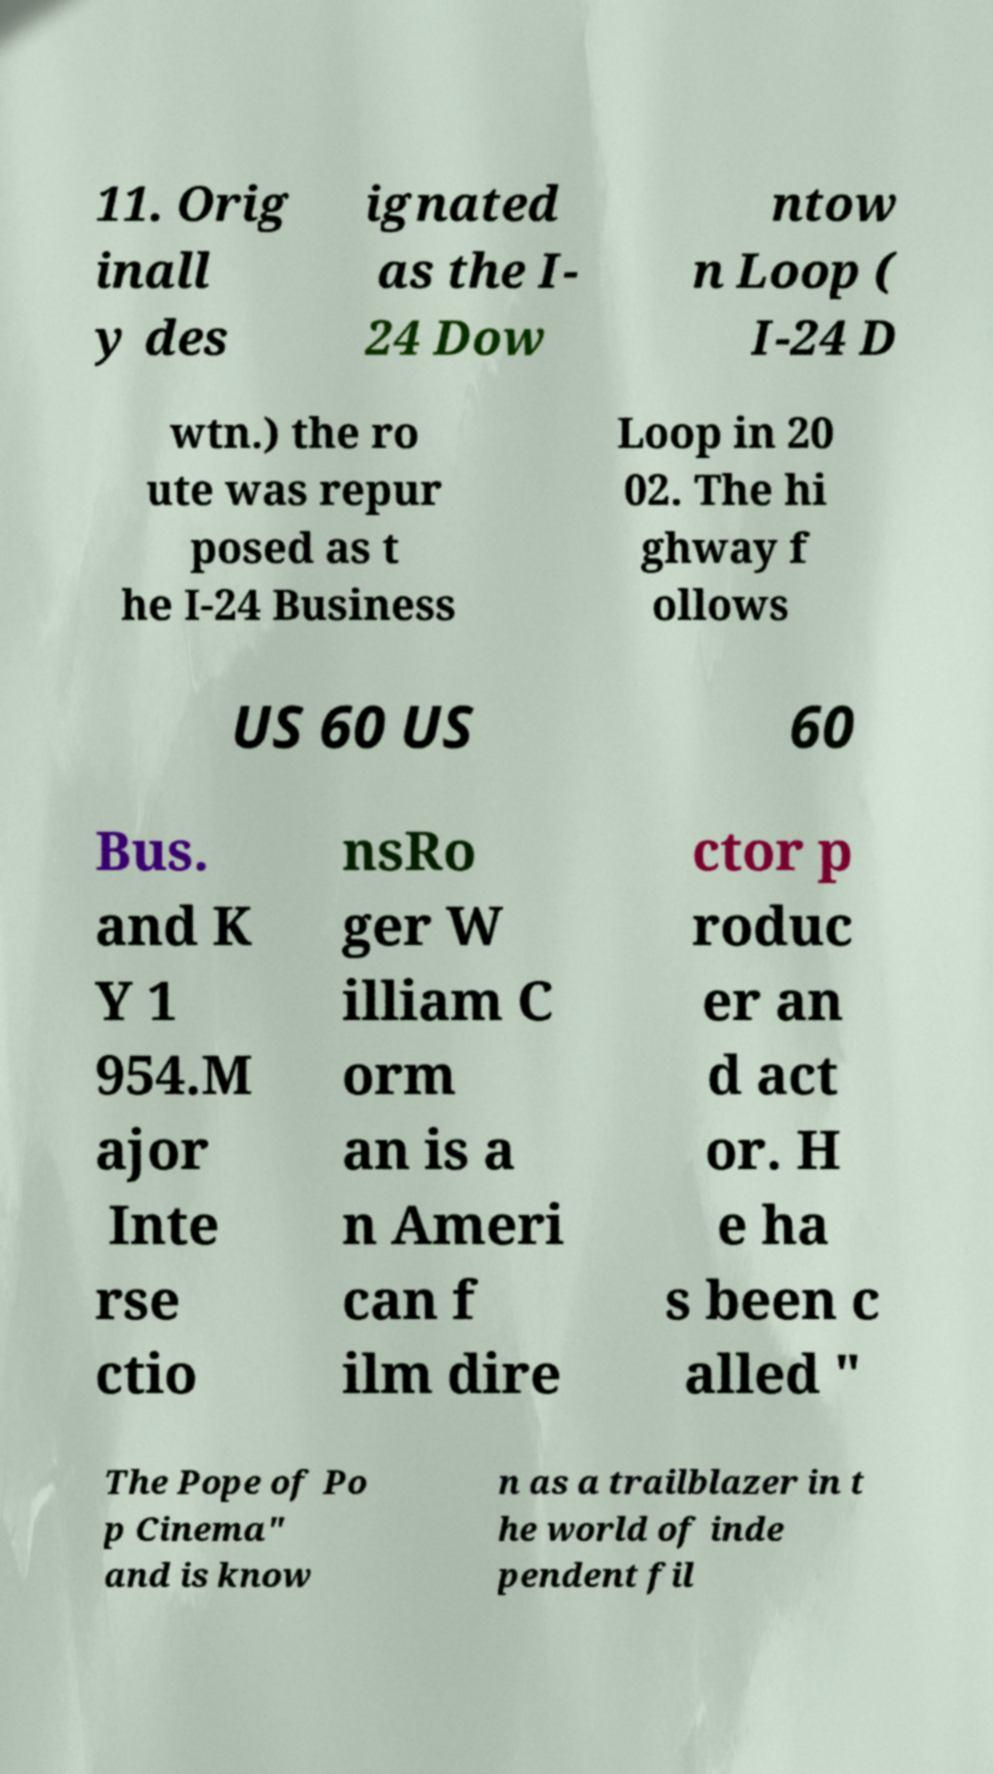There's text embedded in this image that I need extracted. Can you transcribe it verbatim? 11. Orig inall y des ignated as the I- 24 Dow ntow n Loop ( I-24 D wtn.) the ro ute was repur posed as t he I-24 Business Loop in 20 02. The hi ghway f ollows US 60 US 60 Bus. and K Y 1 954.M ajor Inte rse ctio nsRo ger W illiam C orm an is a n Ameri can f ilm dire ctor p roduc er an d act or. H e ha s been c alled " The Pope of Po p Cinema" and is know n as a trailblazer in t he world of inde pendent fil 